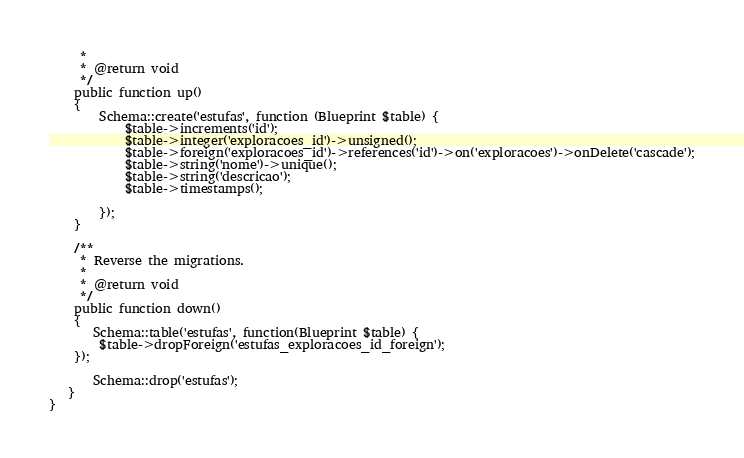Convert code to text. <code><loc_0><loc_0><loc_500><loc_500><_PHP_>     *
     * @return void
     */
    public function up()
    {
        Schema::create('estufas', function (Blueprint $table) {
            $table->increments('id');
            $table->integer('exploracoes_id')->unsigned();
            $table->foreign('exploracoes_id')->references('id')->on('exploracoes')->onDelete('cascade');
            $table->string('nome')->unique();
            $table->string('descricao');            
            $table->timestamps();  

        });
    }

    /**
     * Reverse the migrations.
     *
     * @return void
     */
    public function down()
    {
       Schema::table('estufas', function(Blueprint $table) {
        $table->dropForeign('estufas_exploracoes_id_foreign');
    });

       Schema::drop('estufas');
   }
}
</code> 